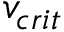<formula> <loc_0><loc_0><loc_500><loc_500>v _ { c r i t }</formula> 